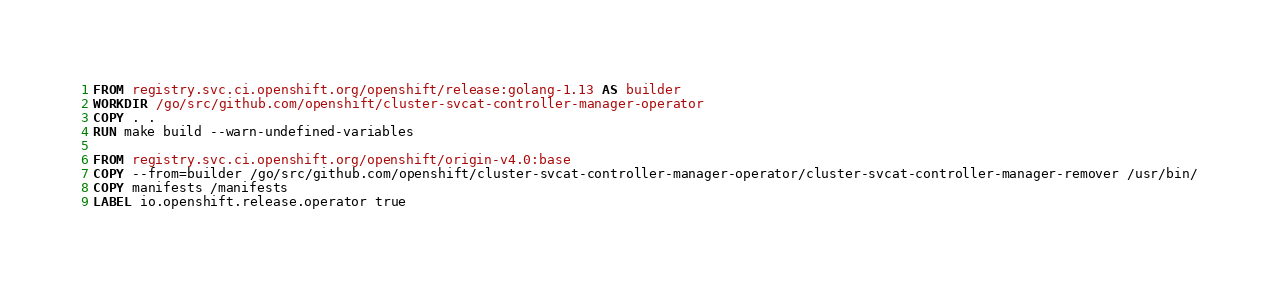Convert code to text. <code><loc_0><loc_0><loc_500><loc_500><_Dockerfile_>FROM registry.svc.ci.openshift.org/openshift/release:golang-1.13 AS builder
WORKDIR /go/src/github.com/openshift/cluster-svcat-controller-manager-operator
COPY . .
RUN make build --warn-undefined-variables

FROM registry.svc.ci.openshift.org/openshift/origin-v4.0:base
COPY --from=builder /go/src/github.com/openshift/cluster-svcat-controller-manager-operator/cluster-svcat-controller-manager-remover /usr/bin/
COPY manifests /manifests
LABEL io.openshift.release.operator true
</code> 